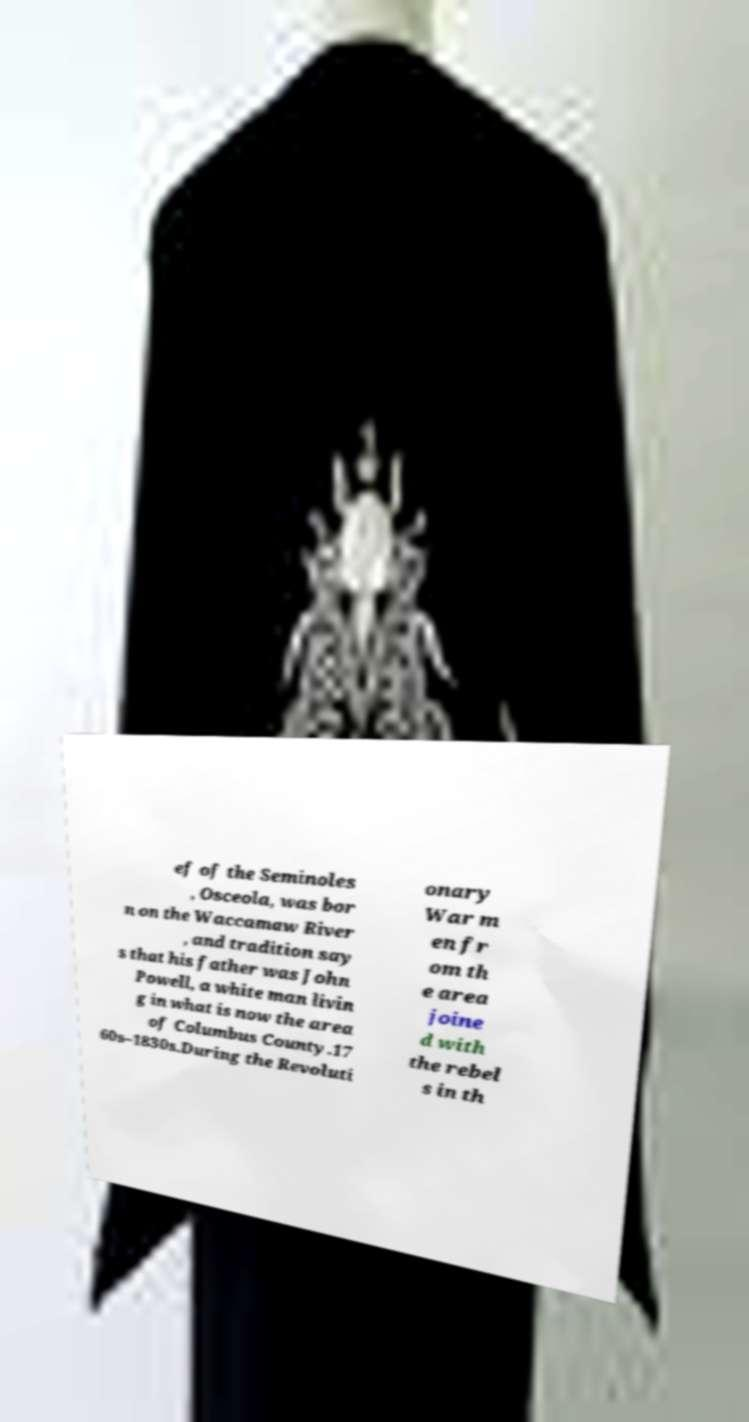Could you assist in decoding the text presented in this image and type it out clearly? ef of the Seminoles , Osceola, was bor n on the Waccamaw River , and tradition say s that his father was John Powell, a white man livin g in what is now the area of Columbus County.17 60s–1830s.During the Revoluti onary War m en fr om th e area joine d with the rebel s in th 